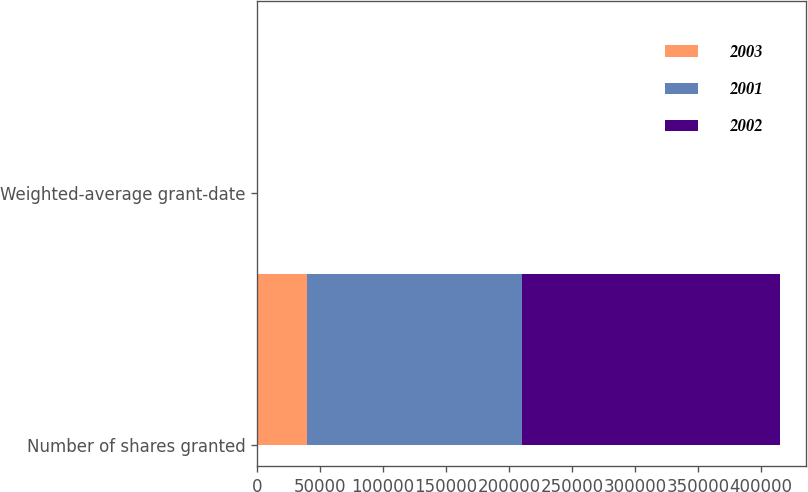Convert chart to OTSL. <chart><loc_0><loc_0><loc_500><loc_500><stacked_bar_chart><ecel><fcel>Number of shares granted<fcel>Weighted-average grant-date<nl><fcel>2003<fcel>39960<fcel>25.52<nl><fcel>2001<fcel>170028<fcel>27.84<nl><fcel>2002<fcel>205346<fcel>31.3<nl></chart> 